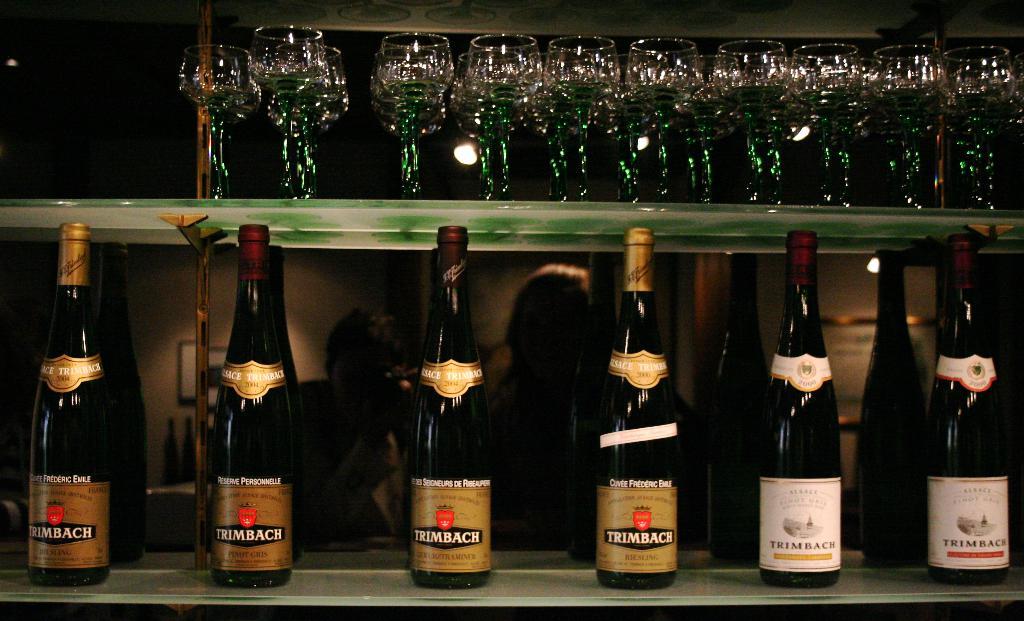What kind of wine is in the bottle on the far right?
Offer a terse response. Trimbach. Are all the bottles trimbach?
Offer a terse response. Yes. 